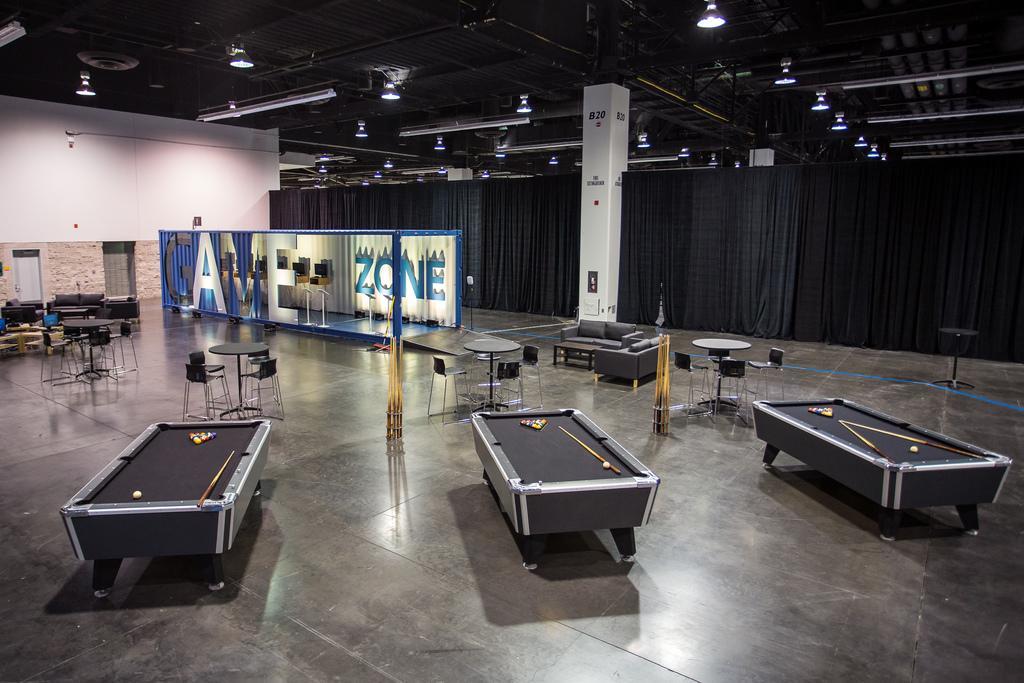Describe this image in one or two sentences. In this image I can see there are snooker boards in black color, balls on them and there are chairs and tables. In the middle there are lights for this game zone. At the top there are lights. 